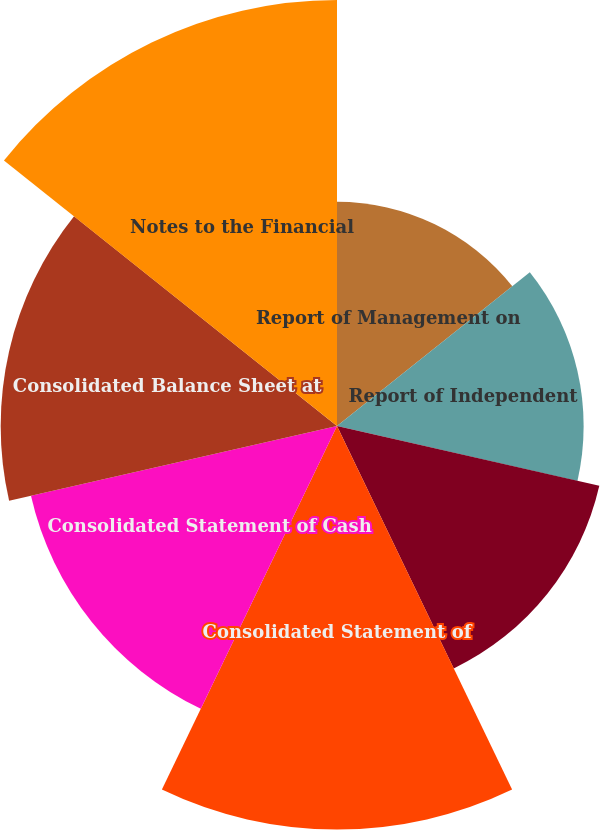<chart> <loc_0><loc_0><loc_500><loc_500><pie_chart><fcel>Report of Management on<fcel>Report of Independent<fcel>Consolidated Income Statement<fcel>Consolidated Statement of<fcel>Consolidated Statement of Cash<fcel>Consolidated Balance Sheet at<fcel>Notes to the Financial<nl><fcel>10.1%<fcel>11.11%<fcel>12.12%<fcel>18.18%<fcel>14.14%<fcel>15.15%<fcel>19.19%<nl></chart> 